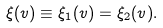Convert formula to latex. <formula><loc_0><loc_0><loc_500><loc_500>\xi ( v ) \equiv \xi _ { 1 } ( v ) = \xi _ { 2 } ( v ) .</formula> 